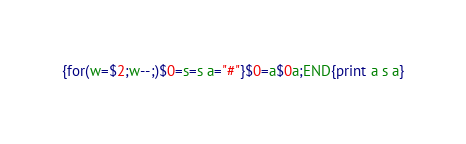<code> <loc_0><loc_0><loc_500><loc_500><_Awk_>{for(w=$2;w--;)$0=s=s a="#"}$0=a$0a;END{print a s a}</code> 